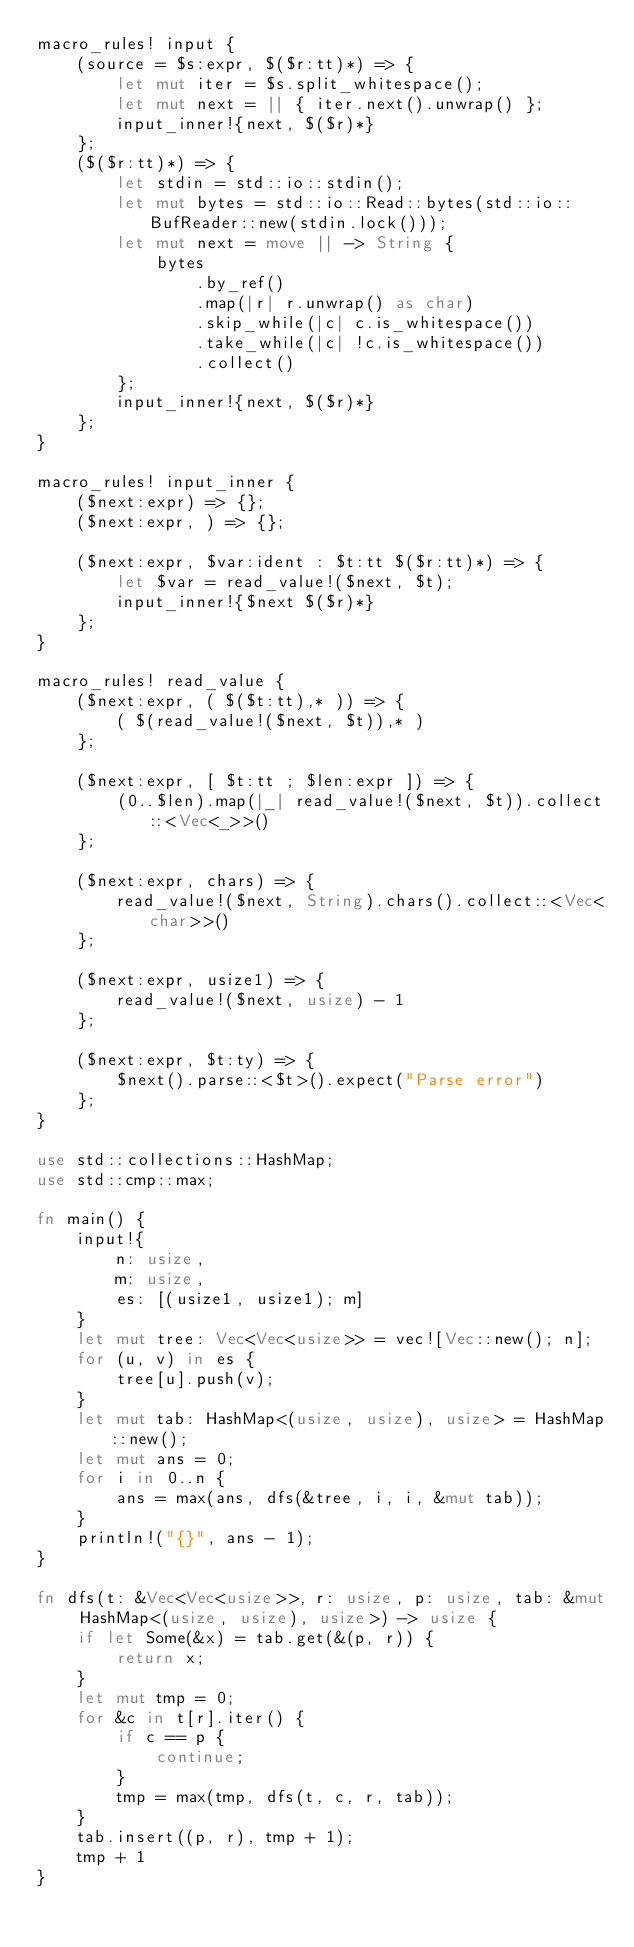<code> <loc_0><loc_0><loc_500><loc_500><_Rust_>macro_rules! input {
    (source = $s:expr, $($r:tt)*) => {
        let mut iter = $s.split_whitespace();
        let mut next = || { iter.next().unwrap() };
        input_inner!{next, $($r)*}
    };
    ($($r:tt)*) => {
        let stdin = std::io::stdin();
        let mut bytes = std::io::Read::bytes(std::io::BufReader::new(stdin.lock()));
        let mut next = move || -> String {
            bytes
                .by_ref()
                .map(|r| r.unwrap() as char)
                .skip_while(|c| c.is_whitespace())
                .take_while(|c| !c.is_whitespace())
                .collect()
        };
        input_inner!{next, $($r)*}
    };
}

macro_rules! input_inner {
    ($next:expr) => {};
    ($next:expr, ) => {};

    ($next:expr, $var:ident : $t:tt $($r:tt)*) => {
        let $var = read_value!($next, $t);
        input_inner!{$next $($r)*}
    };
}

macro_rules! read_value {
    ($next:expr, ( $($t:tt),* )) => {
        ( $(read_value!($next, $t)),* )
    };

    ($next:expr, [ $t:tt ; $len:expr ]) => {
        (0..$len).map(|_| read_value!($next, $t)).collect::<Vec<_>>()
    };

    ($next:expr, chars) => {
        read_value!($next, String).chars().collect::<Vec<char>>()
    };

    ($next:expr, usize1) => {
        read_value!($next, usize) - 1
    };

    ($next:expr, $t:ty) => {
        $next().parse::<$t>().expect("Parse error")
    };
}

use std::collections::HashMap;
use std::cmp::max;

fn main() {
    input!{
        n: usize,
        m: usize,
        es: [(usize1, usize1); m]
    }
    let mut tree: Vec<Vec<usize>> = vec![Vec::new(); n];
    for (u, v) in es {
        tree[u].push(v);
    }
    let mut tab: HashMap<(usize, usize), usize> = HashMap::new();
    let mut ans = 0;
    for i in 0..n {
        ans = max(ans, dfs(&tree, i, i, &mut tab));
    }
    println!("{}", ans - 1);
}

fn dfs(t: &Vec<Vec<usize>>, r: usize, p: usize, tab: &mut HashMap<(usize, usize), usize>) -> usize {
    if let Some(&x) = tab.get(&(p, r)) {
        return x;
    }
    let mut tmp = 0;
    for &c in t[r].iter() {
        if c == p {
            continue;
        }
        tmp = max(tmp, dfs(t, c, r, tab));
    }
    tab.insert((p, r), tmp + 1);
    tmp + 1
}
</code> 